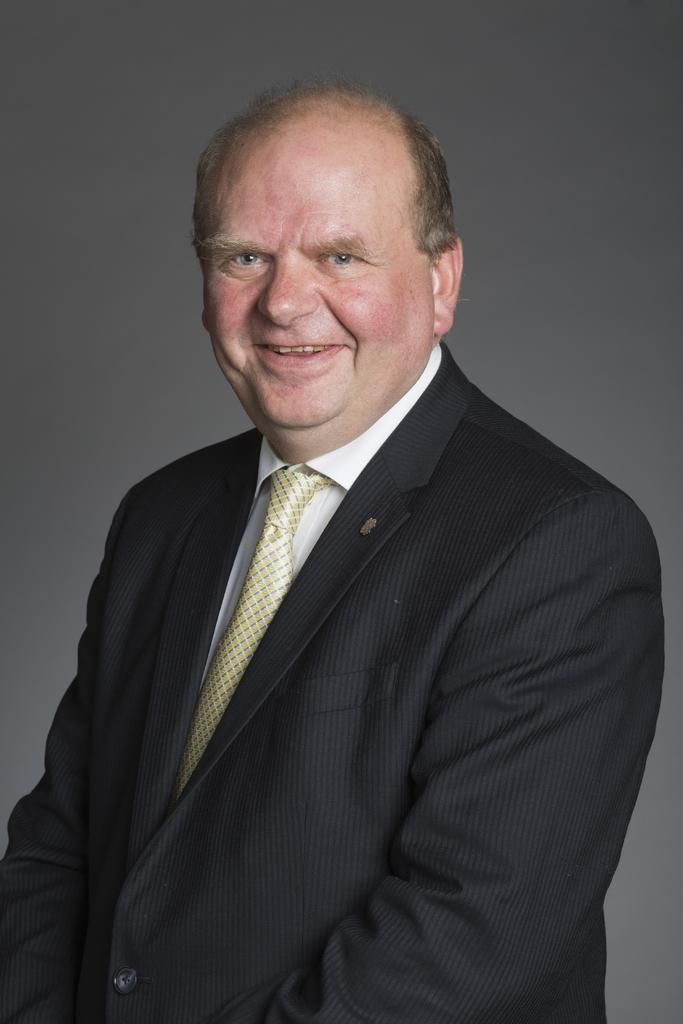What color is the blazer that the person in the image is wearing? The person in the image is wearing a black blazer. What color is the shirt that the person is wearing? The person is wearing a white shirt. What color is the tie that the person is wearing? The person is wearing a cream color tie. What expression does the person have in the image? The person is smiling. What color is the background of the image? The background of the image is grey. What type of pump is visible in the image? There is no pump present in the image. 